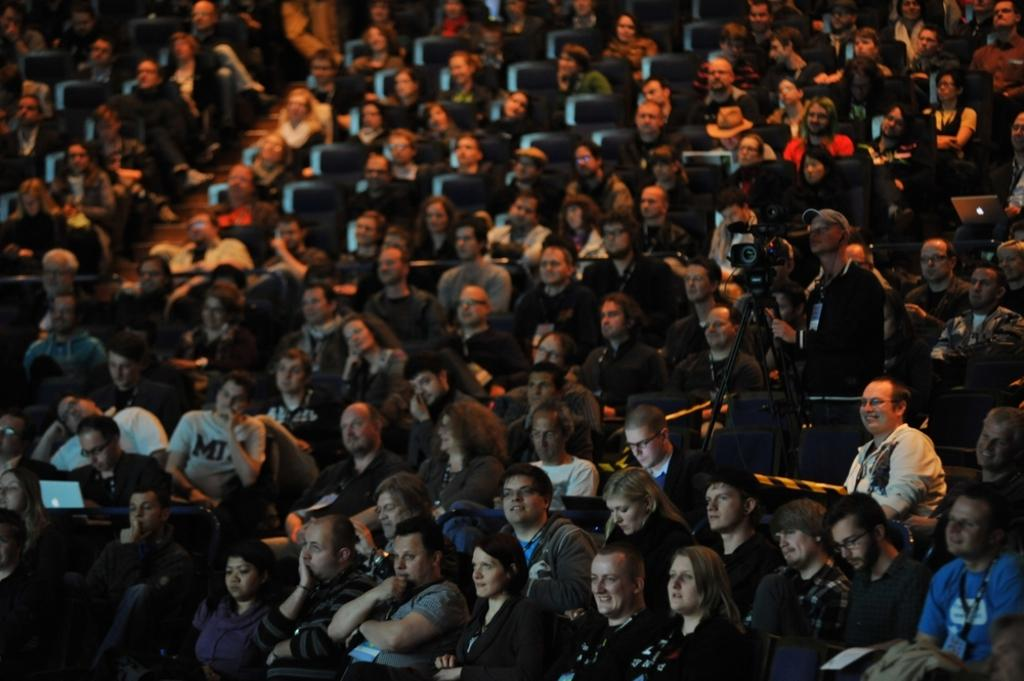What are the people in the image doing? There are many people sitting on chairs in the image. Can you describe the activity of one person in the image? One person is operating a laptop on the left side of the image. What object is located on the right side of the image? There is a camera on the right side of the image. What type of desk is visible in the image? There is no desk present in the image. Can you describe the boat in the image? There is no boat present in the image. 